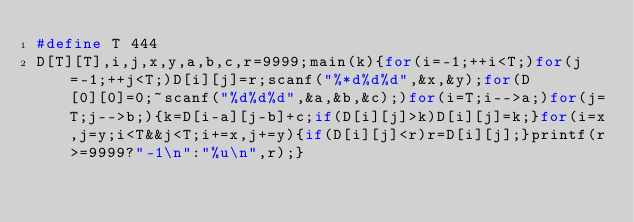Convert code to text. <code><loc_0><loc_0><loc_500><loc_500><_C_>#define T 444
D[T][T],i,j,x,y,a,b,c,r=9999;main(k){for(i=-1;++i<T;)for(j=-1;++j<T;)D[i][j]=r;scanf("%*d%d%d",&x,&y);for(D[0][0]=0;~scanf("%d%d%d",&a,&b,&c);)for(i=T;i-->a;)for(j=T;j-->b;){k=D[i-a][j-b]+c;if(D[i][j]>k)D[i][j]=k;}for(i=x,j=y;i<T&&j<T;i+=x,j+=y){if(D[i][j]<r)r=D[i][j];}printf(r>=9999?"-1\n":"%u\n",r);}</code> 